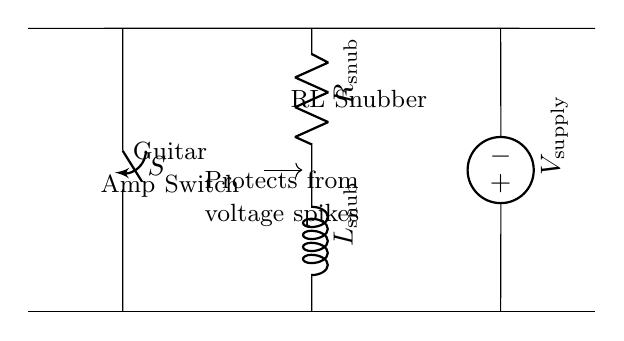What is the role of the switch? The switch is labeled as "S" in the diagram, and it controls the flow of current in the circuit. When the switch is closed, the circuit is completed, allowing current to pass through the RL snubber.
Answer: Control What are the components of the snubber circuit? The snubber circuit consists of a resistor and an inductor, which are labeled as "R" and "L" respectively in the diagram. These components work together to suppress voltage spikes that could damage the amplifier switch.
Answer: Resistor and Inductor What is the voltage source in this circuit? The voltage source is labeled as "V supply" in the circuit, indicating it provides the power needed for the circuit to operate. It connects to the RL snubber and the switch.
Answer: V supply What does the RL snubber protect against? The RL snubber is designed to protect the guitar amplifier switch from voltage spikes, which can occur during switching operations. This is indicated in the circuit diagram with the note stating "Protects from voltage spikes."
Answer: Voltage spikes What happens when the switch is closed? When the switch is closed, it allows current to flow through the RL snubber circuit, enabling it to function by dissipating any potential voltage spikes that might occur, thus protecting the amplifier.
Answer: Current flows 